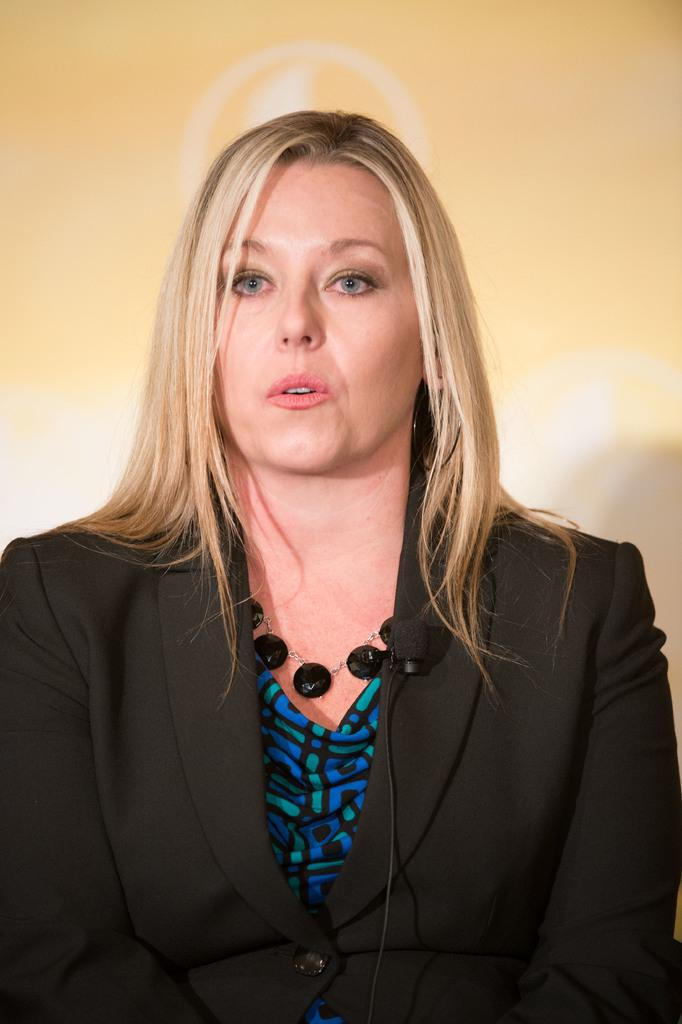What object is present in the image that is used for amplifying sound? There is a mic in the image that is used for amplifying sound. What is connected to the mic in the image? There is a wire in the image that is connected to the mic. What is the woman in the image wearing? The woman is wearing a blazer. What can be seen in the background of the image? There is a wall in the background of the image. How many nerves can be seen in the image? There are no nerves visible in the image. What type of fish is present in the image? There are no fish present in the image. 